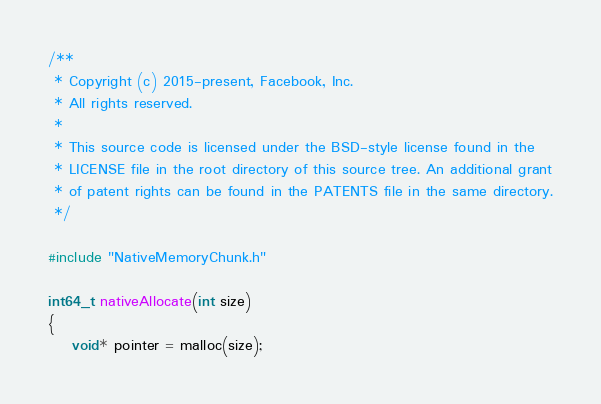Convert code to text. <code><loc_0><loc_0><loc_500><loc_500><_C_>/**
 * Copyright (c) 2015-present, Facebook, Inc.
 * All rights reserved.
 *
 * This source code is licensed under the BSD-style license found in the
 * LICENSE file in the root directory of this source tree. An additional grant
 * of patent rights can be found in the PATENTS file in the same directory.
 */

#include "NativeMemoryChunk.h"

int64_t nativeAllocate(int size)
{
	void* pointer = malloc(size);</code> 